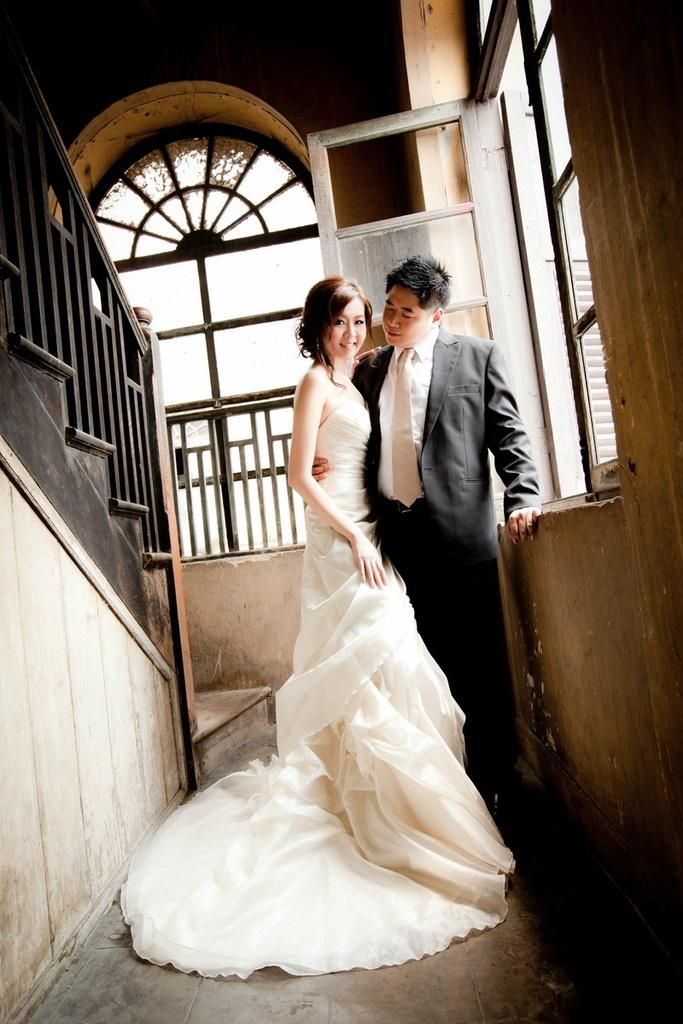How many people are present in the image? There is a woman and a man in the image. What can be seen through the windows in the image? The presence of windows suggests that there might be a view or outdoor scene visible, but the specifics are not mentioned in the facts. What type of architectural feature is present in the image? There is railing in the image. What type of enclosure is present in the image? There are walls in the image. What type of kettle can be seen hanging from the ceiling in the image? There is no kettle present in the image. What type of tent is visible in the background of the image? There is no tent present in the image. 